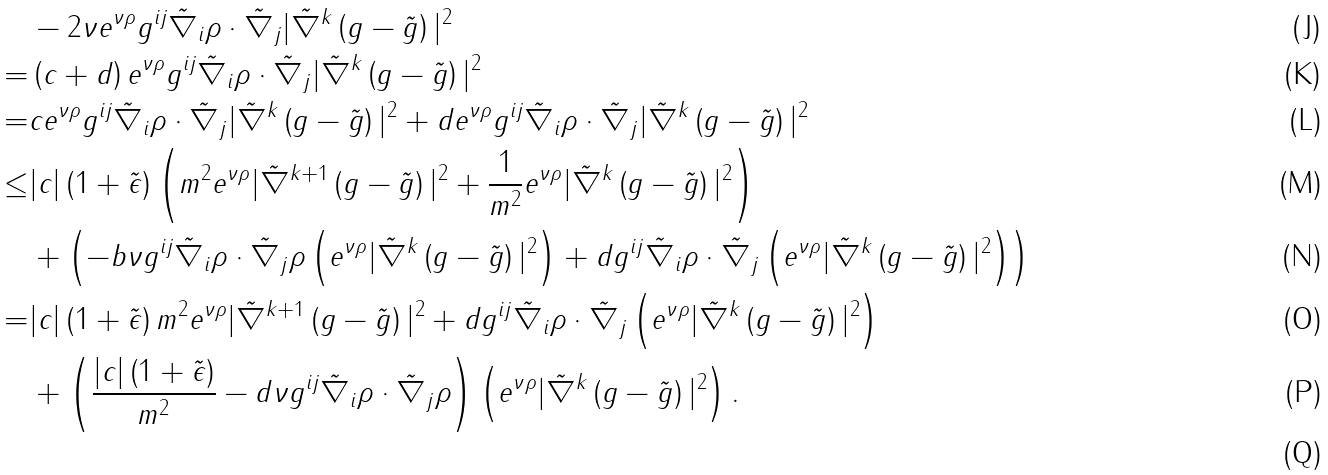Convert formula to latex. <formula><loc_0><loc_0><loc_500><loc_500>& - 2 \nu e ^ { \nu \rho } g ^ { i j } \tilde { \nabla } _ { i } \rho \cdot \tilde { \nabla } _ { j } | \tilde { \nabla } ^ { k } \left ( g - \tilde { g } \right ) | ^ { 2 } \\ = & \left ( c + d \right ) e ^ { \nu \rho } g ^ { i j } \tilde { \nabla } _ { i } \rho \cdot \tilde { \nabla } _ { j } | \tilde { \nabla } ^ { k } \left ( g - \tilde { g } \right ) | ^ { 2 } \\ = & c e ^ { \nu \rho } g ^ { i j } \tilde { \nabla } _ { i } \rho \cdot \tilde { \nabla } _ { j } | \tilde { \nabla } ^ { k } \left ( g - \tilde { g } \right ) | ^ { 2 } + d e ^ { \nu \rho } g ^ { i j } \tilde { \nabla } _ { i } \rho \cdot \tilde { \nabla } _ { j } | \tilde { \nabla } ^ { k } \left ( g - \tilde { g } \right ) | ^ { 2 } \\ \leq & | c | \left ( 1 + \tilde { \epsilon } \right ) \left ( m ^ { 2 } e ^ { \nu \rho } | \tilde { \nabla } ^ { k + 1 } \left ( g - \tilde { g } \right ) | ^ { 2 } + \frac { 1 } { m ^ { 2 } } e ^ { \nu \rho } | \tilde { \nabla } ^ { k } \left ( g - \tilde { g } \right ) | ^ { 2 } \right ) \\ & + \left ( - b \nu g ^ { i j } \tilde { \nabla } _ { i } \rho \cdot \tilde { \nabla } _ { j } \rho \left ( e ^ { \nu \rho } | \tilde { \nabla } ^ { k } \left ( g - \tilde { g } \right ) | ^ { 2 } \right ) + d g ^ { i j } \tilde { \nabla } _ { i } \rho \cdot \tilde { \nabla } _ { j } \left ( e ^ { \nu \rho } | \tilde { \nabla } ^ { k } \left ( g - \tilde { g } \right ) | ^ { 2 } \right ) \right ) \\ = & | c | \left ( 1 + \tilde { \epsilon } \right ) m ^ { 2 } e ^ { \nu \rho } | \tilde { \nabla } ^ { k + 1 } \left ( g - \tilde { g } \right ) | ^ { 2 } + d g ^ { i j } \tilde { \nabla } _ { i } \rho \cdot \tilde { \nabla } _ { j } \left ( e ^ { \nu \rho } | \tilde { \nabla } ^ { k } \left ( g - \tilde { g } \right ) | ^ { 2 } \right ) \\ & + \left ( \frac { | c | \left ( 1 + \tilde { \epsilon } \right ) } { m ^ { 2 } } - d \nu g ^ { i j } \tilde { \nabla } _ { i } \rho \cdot \tilde { \nabla } _ { j } \rho \right ) \left ( e ^ { \nu \rho } | \tilde { \nabla } ^ { k } \left ( g - \tilde { g } \right ) | ^ { 2 } \right ) . \\</formula> 